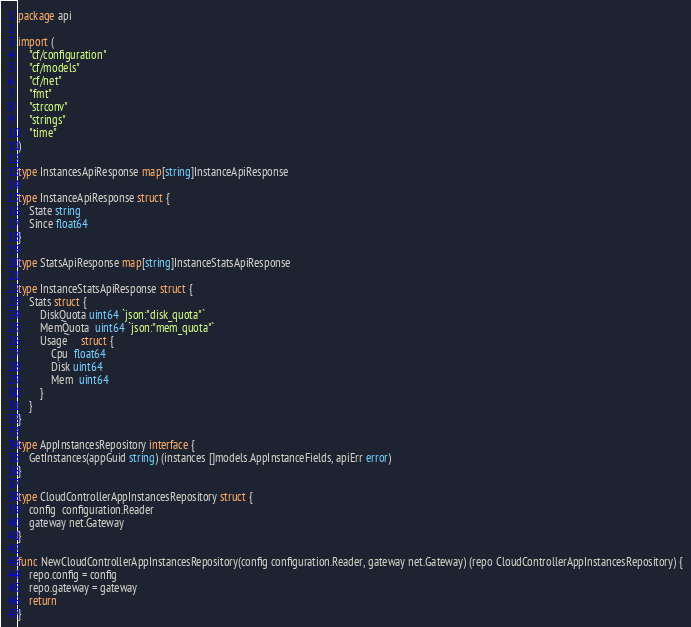<code> <loc_0><loc_0><loc_500><loc_500><_Go_>package api

import (
	"cf/configuration"
	"cf/models"
	"cf/net"
	"fmt"
	"strconv"
	"strings"
	"time"
)

type InstancesApiResponse map[string]InstanceApiResponse

type InstanceApiResponse struct {
	State string
	Since float64
}

type StatsApiResponse map[string]InstanceStatsApiResponse

type InstanceStatsApiResponse struct {
	Stats struct {
		DiskQuota uint64 `json:"disk_quota"`
		MemQuota  uint64 `json:"mem_quota"`
		Usage     struct {
			Cpu  float64
			Disk uint64
			Mem  uint64
		}
	}
}

type AppInstancesRepository interface {
	GetInstances(appGuid string) (instances []models.AppInstanceFields, apiErr error)
}

type CloudControllerAppInstancesRepository struct {
	config  configuration.Reader
	gateway net.Gateway
}

func NewCloudControllerAppInstancesRepository(config configuration.Reader, gateway net.Gateway) (repo CloudControllerAppInstancesRepository) {
	repo.config = config
	repo.gateway = gateway
	return
}
</code> 